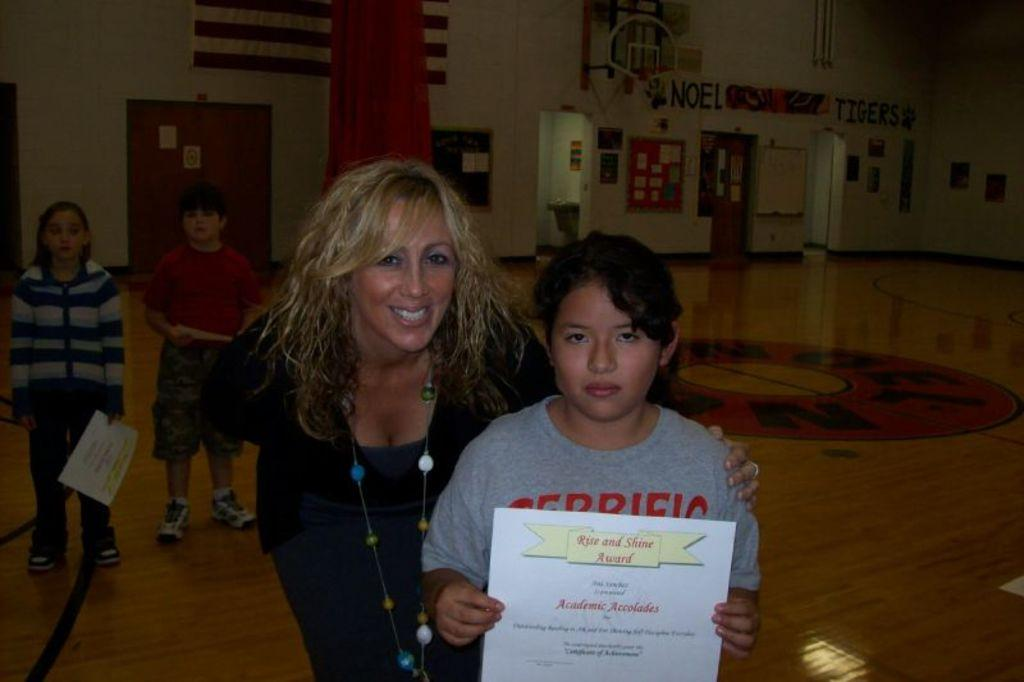How many people are present in the image? There are four people standing in the image. What are three of the people holding? Three people are holding papers. What can be seen in the background of the image? There is a wall in the background of the image. What is attached to the wall? There are boards on the wall. What architectural feature is also present on the wall? There is a door on the wall. What other items are on the wall? There are some objects on the wall. What type of coat is hanging on the door in the image? There is no coat present in the image; the door is on the wall, but no coat is visible. 